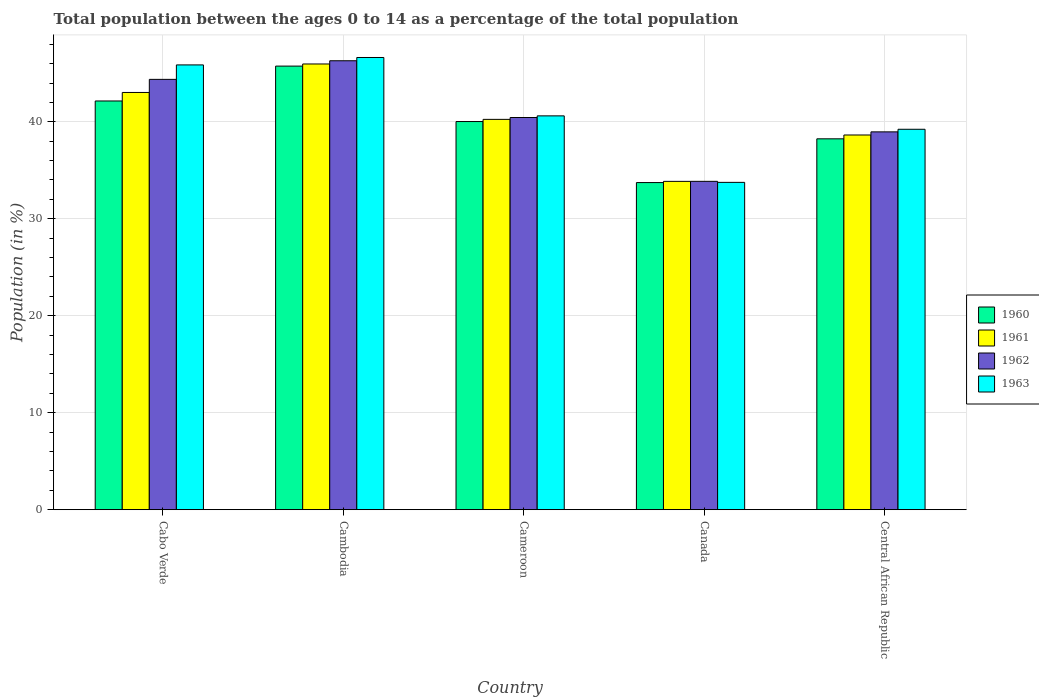Are the number of bars per tick equal to the number of legend labels?
Offer a terse response. Yes. Are the number of bars on each tick of the X-axis equal?
Offer a terse response. Yes. How many bars are there on the 5th tick from the left?
Provide a succinct answer. 4. How many bars are there on the 2nd tick from the right?
Provide a succinct answer. 4. What is the label of the 2nd group of bars from the left?
Provide a succinct answer. Cambodia. What is the percentage of the population ages 0 to 14 in 1962 in Cabo Verde?
Ensure brevity in your answer.  44.38. Across all countries, what is the maximum percentage of the population ages 0 to 14 in 1963?
Offer a very short reply. 46.63. Across all countries, what is the minimum percentage of the population ages 0 to 14 in 1963?
Provide a short and direct response. 33.75. In which country was the percentage of the population ages 0 to 14 in 1961 maximum?
Your answer should be very brief. Cambodia. In which country was the percentage of the population ages 0 to 14 in 1961 minimum?
Give a very brief answer. Canada. What is the total percentage of the population ages 0 to 14 in 1960 in the graph?
Provide a short and direct response. 199.89. What is the difference between the percentage of the population ages 0 to 14 in 1963 in Cambodia and that in Central African Republic?
Your response must be concise. 7.4. What is the difference between the percentage of the population ages 0 to 14 in 1961 in Cabo Verde and the percentage of the population ages 0 to 14 in 1963 in Cameroon?
Keep it short and to the point. 2.41. What is the average percentage of the population ages 0 to 14 in 1960 per country?
Your answer should be compact. 39.98. What is the difference between the percentage of the population ages 0 to 14 of/in 1963 and percentage of the population ages 0 to 14 of/in 1962 in Canada?
Offer a terse response. -0.11. In how many countries, is the percentage of the population ages 0 to 14 in 1961 greater than 42?
Offer a very short reply. 2. What is the ratio of the percentage of the population ages 0 to 14 in 1961 in Cabo Verde to that in Central African Republic?
Offer a very short reply. 1.11. Is the percentage of the population ages 0 to 14 in 1962 in Canada less than that in Central African Republic?
Give a very brief answer. Yes. Is the difference between the percentage of the population ages 0 to 14 in 1963 in Cabo Verde and Canada greater than the difference between the percentage of the population ages 0 to 14 in 1962 in Cabo Verde and Canada?
Provide a succinct answer. Yes. What is the difference between the highest and the second highest percentage of the population ages 0 to 14 in 1960?
Make the answer very short. -2.12. What is the difference between the highest and the lowest percentage of the population ages 0 to 14 in 1960?
Ensure brevity in your answer.  12.01. Is it the case that in every country, the sum of the percentage of the population ages 0 to 14 in 1963 and percentage of the population ages 0 to 14 in 1961 is greater than the sum of percentage of the population ages 0 to 14 in 1960 and percentage of the population ages 0 to 14 in 1962?
Give a very brief answer. No. What does the 3rd bar from the left in Cameroon represents?
Your answer should be compact. 1962. How many countries are there in the graph?
Your response must be concise. 5. What is the difference between two consecutive major ticks on the Y-axis?
Your answer should be compact. 10. Are the values on the major ticks of Y-axis written in scientific E-notation?
Give a very brief answer. No. Does the graph contain any zero values?
Offer a terse response. No. Does the graph contain grids?
Your answer should be compact. Yes. How many legend labels are there?
Offer a very short reply. 4. What is the title of the graph?
Your answer should be compact. Total population between the ages 0 to 14 as a percentage of the total population. What is the label or title of the X-axis?
Make the answer very short. Country. What is the label or title of the Y-axis?
Make the answer very short. Population (in %). What is the Population (in %) in 1960 in Cabo Verde?
Provide a short and direct response. 42.15. What is the Population (in %) of 1961 in Cabo Verde?
Your answer should be very brief. 43.02. What is the Population (in %) in 1962 in Cabo Verde?
Offer a terse response. 44.38. What is the Population (in %) in 1963 in Cabo Verde?
Provide a succinct answer. 45.86. What is the Population (in %) of 1960 in Cambodia?
Your answer should be compact. 45.74. What is the Population (in %) of 1961 in Cambodia?
Give a very brief answer. 45.96. What is the Population (in %) in 1962 in Cambodia?
Ensure brevity in your answer.  46.29. What is the Population (in %) in 1963 in Cambodia?
Offer a terse response. 46.63. What is the Population (in %) in 1960 in Cameroon?
Offer a very short reply. 40.03. What is the Population (in %) of 1961 in Cameroon?
Keep it short and to the point. 40.25. What is the Population (in %) in 1962 in Cameroon?
Provide a short and direct response. 40.44. What is the Population (in %) in 1963 in Cameroon?
Your response must be concise. 40.61. What is the Population (in %) of 1960 in Canada?
Offer a very short reply. 33.73. What is the Population (in %) of 1961 in Canada?
Provide a short and direct response. 33.86. What is the Population (in %) in 1962 in Canada?
Your answer should be compact. 33.86. What is the Population (in %) of 1963 in Canada?
Ensure brevity in your answer.  33.75. What is the Population (in %) in 1960 in Central African Republic?
Provide a succinct answer. 38.24. What is the Population (in %) of 1961 in Central African Republic?
Offer a terse response. 38.64. What is the Population (in %) in 1962 in Central African Republic?
Your response must be concise. 38.96. What is the Population (in %) in 1963 in Central African Republic?
Your answer should be compact. 39.23. Across all countries, what is the maximum Population (in %) in 1960?
Your response must be concise. 45.74. Across all countries, what is the maximum Population (in %) of 1961?
Provide a succinct answer. 45.96. Across all countries, what is the maximum Population (in %) in 1962?
Your response must be concise. 46.29. Across all countries, what is the maximum Population (in %) of 1963?
Offer a terse response. 46.63. Across all countries, what is the minimum Population (in %) of 1960?
Your answer should be very brief. 33.73. Across all countries, what is the minimum Population (in %) in 1961?
Offer a terse response. 33.86. Across all countries, what is the minimum Population (in %) in 1962?
Ensure brevity in your answer.  33.86. Across all countries, what is the minimum Population (in %) of 1963?
Your answer should be very brief. 33.75. What is the total Population (in %) of 1960 in the graph?
Ensure brevity in your answer.  199.89. What is the total Population (in %) in 1961 in the graph?
Provide a short and direct response. 201.73. What is the total Population (in %) of 1962 in the graph?
Your response must be concise. 203.93. What is the total Population (in %) of 1963 in the graph?
Provide a succinct answer. 206.09. What is the difference between the Population (in %) of 1960 in Cabo Verde and that in Cambodia?
Offer a very short reply. -3.6. What is the difference between the Population (in %) of 1961 in Cabo Verde and that in Cambodia?
Give a very brief answer. -2.94. What is the difference between the Population (in %) of 1962 in Cabo Verde and that in Cambodia?
Provide a short and direct response. -1.92. What is the difference between the Population (in %) of 1963 in Cabo Verde and that in Cambodia?
Offer a very short reply. -0.77. What is the difference between the Population (in %) of 1960 in Cabo Verde and that in Cameroon?
Offer a terse response. 2.12. What is the difference between the Population (in %) of 1961 in Cabo Verde and that in Cameroon?
Keep it short and to the point. 2.78. What is the difference between the Population (in %) of 1962 in Cabo Verde and that in Cameroon?
Offer a terse response. 3.93. What is the difference between the Population (in %) of 1963 in Cabo Verde and that in Cameroon?
Offer a terse response. 5.25. What is the difference between the Population (in %) in 1960 in Cabo Verde and that in Canada?
Your answer should be compact. 8.41. What is the difference between the Population (in %) in 1961 in Cabo Verde and that in Canada?
Your response must be concise. 9.17. What is the difference between the Population (in %) in 1962 in Cabo Verde and that in Canada?
Offer a terse response. 10.52. What is the difference between the Population (in %) of 1963 in Cabo Verde and that in Canada?
Provide a succinct answer. 12.11. What is the difference between the Population (in %) of 1960 in Cabo Verde and that in Central African Republic?
Offer a terse response. 3.9. What is the difference between the Population (in %) of 1961 in Cabo Verde and that in Central African Republic?
Give a very brief answer. 4.39. What is the difference between the Population (in %) of 1962 in Cabo Verde and that in Central African Republic?
Your answer should be very brief. 5.41. What is the difference between the Population (in %) in 1963 in Cabo Verde and that in Central African Republic?
Provide a succinct answer. 6.64. What is the difference between the Population (in %) of 1960 in Cambodia and that in Cameroon?
Ensure brevity in your answer.  5.72. What is the difference between the Population (in %) of 1961 in Cambodia and that in Cameroon?
Your answer should be very brief. 5.71. What is the difference between the Population (in %) of 1962 in Cambodia and that in Cameroon?
Provide a short and direct response. 5.85. What is the difference between the Population (in %) of 1963 in Cambodia and that in Cameroon?
Your answer should be compact. 6.02. What is the difference between the Population (in %) in 1960 in Cambodia and that in Canada?
Provide a succinct answer. 12.01. What is the difference between the Population (in %) in 1961 in Cambodia and that in Canada?
Your answer should be very brief. 12.11. What is the difference between the Population (in %) of 1962 in Cambodia and that in Canada?
Offer a very short reply. 12.43. What is the difference between the Population (in %) in 1963 in Cambodia and that in Canada?
Offer a terse response. 12.88. What is the difference between the Population (in %) of 1960 in Cambodia and that in Central African Republic?
Your answer should be compact. 7.5. What is the difference between the Population (in %) in 1961 in Cambodia and that in Central African Republic?
Offer a very short reply. 7.32. What is the difference between the Population (in %) in 1962 in Cambodia and that in Central African Republic?
Keep it short and to the point. 7.33. What is the difference between the Population (in %) in 1963 in Cambodia and that in Central African Republic?
Offer a very short reply. 7.4. What is the difference between the Population (in %) of 1960 in Cameroon and that in Canada?
Your answer should be compact. 6.29. What is the difference between the Population (in %) in 1961 in Cameroon and that in Canada?
Make the answer very short. 6.39. What is the difference between the Population (in %) of 1962 in Cameroon and that in Canada?
Provide a succinct answer. 6.58. What is the difference between the Population (in %) in 1963 in Cameroon and that in Canada?
Make the answer very short. 6.86. What is the difference between the Population (in %) in 1960 in Cameroon and that in Central African Republic?
Offer a very short reply. 1.78. What is the difference between the Population (in %) of 1961 in Cameroon and that in Central African Republic?
Give a very brief answer. 1.61. What is the difference between the Population (in %) in 1962 in Cameroon and that in Central African Republic?
Offer a terse response. 1.48. What is the difference between the Population (in %) of 1963 in Cameroon and that in Central African Republic?
Give a very brief answer. 1.38. What is the difference between the Population (in %) in 1960 in Canada and that in Central African Republic?
Ensure brevity in your answer.  -4.51. What is the difference between the Population (in %) in 1961 in Canada and that in Central African Republic?
Ensure brevity in your answer.  -4.78. What is the difference between the Population (in %) in 1962 in Canada and that in Central African Republic?
Keep it short and to the point. -5.1. What is the difference between the Population (in %) of 1963 in Canada and that in Central African Republic?
Provide a short and direct response. -5.47. What is the difference between the Population (in %) in 1960 in Cabo Verde and the Population (in %) in 1961 in Cambodia?
Your answer should be compact. -3.82. What is the difference between the Population (in %) of 1960 in Cabo Verde and the Population (in %) of 1962 in Cambodia?
Your answer should be very brief. -4.15. What is the difference between the Population (in %) in 1960 in Cabo Verde and the Population (in %) in 1963 in Cambodia?
Provide a short and direct response. -4.48. What is the difference between the Population (in %) in 1961 in Cabo Verde and the Population (in %) in 1962 in Cambodia?
Ensure brevity in your answer.  -3.27. What is the difference between the Population (in %) in 1961 in Cabo Verde and the Population (in %) in 1963 in Cambodia?
Make the answer very short. -3.61. What is the difference between the Population (in %) of 1962 in Cabo Verde and the Population (in %) of 1963 in Cambodia?
Offer a very short reply. -2.26. What is the difference between the Population (in %) in 1960 in Cabo Verde and the Population (in %) in 1961 in Cameroon?
Your answer should be compact. 1.9. What is the difference between the Population (in %) of 1960 in Cabo Verde and the Population (in %) of 1962 in Cameroon?
Offer a very short reply. 1.71. What is the difference between the Population (in %) of 1960 in Cabo Verde and the Population (in %) of 1963 in Cameroon?
Your answer should be very brief. 1.54. What is the difference between the Population (in %) of 1961 in Cabo Verde and the Population (in %) of 1962 in Cameroon?
Offer a very short reply. 2.58. What is the difference between the Population (in %) of 1961 in Cabo Verde and the Population (in %) of 1963 in Cameroon?
Your answer should be very brief. 2.41. What is the difference between the Population (in %) in 1962 in Cabo Verde and the Population (in %) in 1963 in Cameroon?
Make the answer very short. 3.76. What is the difference between the Population (in %) in 1960 in Cabo Verde and the Population (in %) in 1961 in Canada?
Offer a very short reply. 8.29. What is the difference between the Population (in %) of 1960 in Cabo Verde and the Population (in %) of 1962 in Canada?
Make the answer very short. 8.29. What is the difference between the Population (in %) of 1960 in Cabo Verde and the Population (in %) of 1963 in Canada?
Ensure brevity in your answer.  8.39. What is the difference between the Population (in %) in 1961 in Cabo Verde and the Population (in %) in 1962 in Canada?
Make the answer very short. 9.16. What is the difference between the Population (in %) of 1961 in Cabo Verde and the Population (in %) of 1963 in Canada?
Make the answer very short. 9.27. What is the difference between the Population (in %) in 1962 in Cabo Verde and the Population (in %) in 1963 in Canada?
Offer a very short reply. 10.62. What is the difference between the Population (in %) in 1960 in Cabo Verde and the Population (in %) in 1961 in Central African Republic?
Your response must be concise. 3.51. What is the difference between the Population (in %) of 1960 in Cabo Verde and the Population (in %) of 1962 in Central African Republic?
Keep it short and to the point. 3.19. What is the difference between the Population (in %) in 1960 in Cabo Verde and the Population (in %) in 1963 in Central African Republic?
Your response must be concise. 2.92. What is the difference between the Population (in %) of 1961 in Cabo Verde and the Population (in %) of 1962 in Central African Republic?
Give a very brief answer. 4.06. What is the difference between the Population (in %) of 1961 in Cabo Verde and the Population (in %) of 1963 in Central African Republic?
Ensure brevity in your answer.  3.8. What is the difference between the Population (in %) of 1962 in Cabo Verde and the Population (in %) of 1963 in Central African Republic?
Your response must be concise. 5.15. What is the difference between the Population (in %) of 1960 in Cambodia and the Population (in %) of 1961 in Cameroon?
Ensure brevity in your answer.  5.49. What is the difference between the Population (in %) in 1960 in Cambodia and the Population (in %) in 1962 in Cameroon?
Your answer should be compact. 5.3. What is the difference between the Population (in %) in 1960 in Cambodia and the Population (in %) in 1963 in Cameroon?
Ensure brevity in your answer.  5.13. What is the difference between the Population (in %) in 1961 in Cambodia and the Population (in %) in 1962 in Cameroon?
Your response must be concise. 5.52. What is the difference between the Population (in %) of 1961 in Cambodia and the Population (in %) of 1963 in Cameroon?
Make the answer very short. 5.35. What is the difference between the Population (in %) of 1962 in Cambodia and the Population (in %) of 1963 in Cameroon?
Give a very brief answer. 5.68. What is the difference between the Population (in %) in 1960 in Cambodia and the Population (in %) in 1961 in Canada?
Provide a short and direct response. 11.89. What is the difference between the Population (in %) in 1960 in Cambodia and the Population (in %) in 1962 in Canada?
Your response must be concise. 11.88. What is the difference between the Population (in %) in 1960 in Cambodia and the Population (in %) in 1963 in Canada?
Provide a short and direct response. 11.99. What is the difference between the Population (in %) in 1961 in Cambodia and the Population (in %) in 1962 in Canada?
Provide a succinct answer. 12.1. What is the difference between the Population (in %) in 1961 in Cambodia and the Population (in %) in 1963 in Canada?
Make the answer very short. 12.21. What is the difference between the Population (in %) in 1962 in Cambodia and the Population (in %) in 1963 in Canada?
Offer a terse response. 12.54. What is the difference between the Population (in %) of 1960 in Cambodia and the Population (in %) of 1961 in Central African Republic?
Ensure brevity in your answer.  7.1. What is the difference between the Population (in %) of 1960 in Cambodia and the Population (in %) of 1962 in Central African Republic?
Your answer should be very brief. 6.78. What is the difference between the Population (in %) in 1960 in Cambodia and the Population (in %) in 1963 in Central African Republic?
Your answer should be compact. 6.52. What is the difference between the Population (in %) of 1961 in Cambodia and the Population (in %) of 1962 in Central African Republic?
Offer a very short reply. 7. What is the difference between the Population (in %) in 1961 in Cambodia and the Population (in %) in 1963 in Central African Republic?
Your response must be concise. 6.73. What is the difference between the Population (in %) in 1962 in Cambodia and the Population (in %) in 1963 in Central African Republic?
Make the answer very short. 7.07. What is the difference between the Population (in %) in 1960 in Cameroon and the Population (in %) in 1961 in Canada?
Your answer should be very brief. 6.17. What is the difference between the Population (in %) of 1960 in Cameroon and the Population (in %) of 1962 in Canada?
Provide a succinct answer. 6.17. What is the difference between the Population (in %) in 1960 in Cameroon and the Population (in %) in 1963 in Canada?
Offer a very short reply. 6.27. What is the difference between the Population (in %) in 1961 in Cameroon and the Population (in %) in 1962 in Canada?
Make the answer very short. 6.39. What is the difference between the Population (in %) of 1961 in Cameroon and the Population (in %) of 1963 in Canada?
Keep it short and to the point. 6.5. What is the difference between the Population (in %) in 1962 in Cameroon and the Population (in %) in 1963 in Canada?
Ensure brevity in your answer.  6.69. What is the difference between the Population (in %) of 1960 in Cameroon and the Population (in %) of 1961 in Central African Republic?
Give a very brief answer. 1.39. What is the difference between the Population (in %) in 1960 in Cameroon and the Population (in %) in 1962 in Central African Republic?
Your answer should be very brief. 1.07. What is the difference between the Population (in %) of 1960 in Cameroon and the Population (in %) of 1963 in Central African Republic?
Ensure brevity in your answer.  0.8. What is the difference between the Population (in %) of 1961 in Cameroon and the Population (in %) of 1962 in Central African Republic?
Ensure brevity in your answer.  1.29. What is the difference between the Population (in %) of 1961 in Cameroon and the Population (in %) of 1963 in Central African Republic?
Offer a very short reply. 1.02. What is the difference between the Population (in %) of 1962 in Cameroon and the Population (in %) of 1963 in Central African Republic?
Offer a very short reply. 1.21. What is the difference between the Population (in %) of 1960 in Canada and the Population (in %) of 1961 in Central African Republic?
Provide a short and direct response. -4.91. What is the difference between the Population (in %) in 1960 in Canada and the Population (in %) in 1962 in Central African Republic?
Your answer should be compact. -5.23. What is the difference between the Population (in %) of 1960 in Canada and the Population (in %) of 1963 in Central African Republic?
Provide a succinct answer. -5.5. What is the difference between the Population (in %) in 1961 in Canada and the Population (in %) in 1962 in Central African Republic?
Offer a terse response. -5.1. What is the difference between the Population (in %) of 1961 in Canada and the Population (in %) of 1963 in Central African Republic?
Give a very brief answer. -5.37. What is the difference between the Population (in %) in 1962 in Canada and the Population (in %) in 1963 in Central African Republic?
Provide a succinct answer. -5.37. What is the average Population (in %) in 1960 per country?
Ensure brevity in your answer.  39.98. What is the average Population (in %) in 1961 per country?
Your response must be concise. 40.35. What is the average Population (in %) of 1962 per country?
Offer a terse response. 40.79. What is the average Population (in %) of 1963 per country?
Ensure brevity in your answer.  41.22. What is the difference between the Population (in %) in 1960 and Population (in %) in 1961 in Cabo Verde?
Give a very brief answer. -0.88. What is the difference between the Population (in %) of 1960 and Population (in %) of 1962 in Cabo Verde?
Provide a succinct answer. -2.23. What is the difference between the Population (in %) in 1960 and Population (in %) in 1963 in Cabo Verde?
Make the answer very short. -3.72. What is the difference between the Population (in %) of 1961 and Population (in %) of 1962 in Cabo Verde?
Provide a succinct answer. -1.35. What is the difference between the Population (in %) of 1961 and Population (in %) of 1963 in Cabo Verde?
Offer a very short reply. -2.84. What is the difference between the Population (in %) of 1962 and Population (in %) of 1963 in Cabo Verde?
Ensure brevity in your answer.  -1.49. What is the difference between the Population (in %) in 1960 and Population (in %) in 1961 in Cambodia?
Your answer should be compact. -0.22. What is the difference between the Population (in %) in 1960 and Population (in %) in 1962 in Cambodia?
Give a very brief answer. -0.55. What is the difference between the Population (in %) of 1960 and Population (in %) of 1963 in Cambodia?
Your response must be concise. -0.89. What is the difference between the Population (in %) in 1961 and Population (in %) in 1962 in Cambodia?
Your answer should be very brief. -0.33. What is the difference between the Population (in %) of 1961 and Population (in %) of 1963 in Cambodia?
Keep it short and to the point. -0.67. What is the difference between the Population (in %) of 1962 and Population (in %) of 1963 in Cambodia?
Make the answer very short. -0.34. What is the difference between the Population (in %) of 1960 and Population (in %) of 1961 in Cameroon?
Offer a very short reply. -0.22. What is the difference between the Population (in %) in 1960 and Population (in %) in 1962 in Cameroon?
Ensure brevity in your answer.  -0.41. What is the difference between the Population (in %) of 1960 and Population (in %) of 1963 in Cameroon?
Give a very brief answer. -0.58. What is the difference between the Population (in %) of 1961 and Population (in %) of 1962 in Cameroon?
Ensure brevity in your answer.  -0.19. What is the difference between the Population (in %) in 1961 and Population (in %) in 1963 in Cameroon?
Offer a very short reply. -0.36. What is the difference between the Population (in %) of 1962 and Population (in %) of 1963 in Cameroon?
Offer a very short reply. -0.17. What is the difference between the Population (in %) in 1960 and Population (in %) in 1961 in Canada?
Your answer should be compact. -0.12. What is the difference between the Population (in %) of 1960 and Population (in %) of 1962 in Canada?
Keep it short and to the point. -0.13. What is the difference between the Population (in %) in 1960 and Population (in %) in 1963 in Canada?
Ensure brevity in your answer.  -0.02. What is the difference between the Population (in %) in 1961 and Population (in %) in 1962 in Canada?
Keep it short and to the point. -0. What is the difference between the Population (in %) of 1961 and Population (in %) of 1963 in Canada?
Make the answer very short. 0.1. What is the difference between the Population (in %) in 1962 and Population (in %) in 1963 in Canada?
Your answer should be very brief. 0.11. What is the difference between the Population (in %) in 1960 and Population (in %) in 1961 in Central African Republic?
Keep it short and to the point. -0.39. What is the difference between the Population (in %) of 1960 and Population (in %) of 1962 in Central African Republic?
Ensure brevity in your answer.  -0.72. What is the difference between the Population (in %) of 1960 and Population (in %) of 1963 in Central African Republic?
Offer a very short reply. -0.98. What is the difference between the Population (in %) of 1961 and Population (in %) of 1962 in Central African Republic?
Provide a short and direct response. -0.32. What is the difference between the Population (in %) in 1961 and Population (in %) in 1963 in Central African Republic?
Make the answer very short. -0.59. What is the difference between the Population (in %) in 1962 and Population (in %) in 1963 in Central African Republic?
Provide a short and direct response. -0.27. What is the ratio of the Population (in %) in 1960 in Cabo Verde to that in Cambodia?
Provide a short and direct response. 0.92. What is the ratio of the Population (in %) in 1961 in Cabo Verde to that in Cambodia?
Offer a terse response. 0.94. What is the ratio of the Population (in %) in 1962 in Cabo Verde to that in Cambodia?
Offer a terse response. 0.96. What is the ratio of the Population (in %) in 1963 in Cabo Verde to that in Cambodia?
Your answer should be compact. 0.98. What is the ratio of the Population (in %) of 1960 in Cabo Verde to that in Cameroon?
Your answer should be very brief. 1.05. What is the ratio of the Population (in %) in 1961 in Cabo Verde to that in Cameroon?
Your answer should be compact. 1.07. What is the ratio of the Population (in %) in 1962 in Cabo Verde to that in Cameroon?
Keep it short and to the point. 1.1. What is the ratio of the Population (in %) of 1963 in Cabo Verde to that in Cameroon?
Keep it short and to the point. 1.13. What is the ratio of the Population (in %) of 1960 in Cabo Verde to that in Canada?
Give a very brief answer. 1.25. What is the ratio of the Population (in %) of 1961 in Cabo Verde to that in Canada?
Your answer should be very brief. 1.27. What is the ratio of the Population (in %) of 1962 in Cabo Verde to that in Canada?
Your answer should be compact. 1.31. What is the ratio of the Population (in %) of 1963 in Cabo Verde to that in Canada?
Make the answer very short. 1.36. What is the ratio of the Population (in %) in 1960 in Cabo Verde to that in Central African Republic?
Provide a succinct answer. 1.1. What is the ratio of the Population (in %) in 1961 in Cabo Verde to that in Central African Republic?
Your answer should be very brief. 1.11. What is the ratio of the Population (in %) of 1962 in Cabo Verde to that in Central African Republic?
Provide a succinct answer. 1.14. What is the ratio of the Population (in %) of 1963 in Cabo Verde to that in Central African Republic?
Provide a succinct answer. 1.17. What is the ratio of the Population (in %) of 1960 in Cambodia to that in Cameroon?
Your answer should be compact. 1.14. What is the ratio of the Population (in %) in 1961 in Cambodia to that in Cameroon?
Ensure brevity in your answer.  1.14. What is the ratio of the Population (in %) in 1962 in Cambodia to that in Cameroon?
Provide a succinct answer. 1.14. What is the ratio of the Population (in %) of 1963 in Cambodia to that in Cameroon?
Your response must be concise. 1.15. What is the ratio of the Population (in %) in 1960 in Cambodia to that in Canada?
Make the answer very short. 1.36. What is the ratio of the Population (in %) of 1961 in Cambodia to that in Canada?
Keep it short and to the point. 1.36. What is the ratio of the Population (in %) of 1962 in Cambodia to that in Canada?
Your answer should be very brief. 1.37. What is the ratio of the Population (in %) of 1963 in Cambodia to that in Canada?
Offer a very short reply. 1.38. What is the ratio of the Population (in %) of 1960 in Cambodia to that in Central African Republic?
Provide a short and direct response. 1.2. What is the ratio of the Population (in %) in 1961 in Cambodia to that in Central African Republic?
Your answer should be very brief. 1.19. What is the ratio of the Population (in %) of 1962 in Cambodia to that in Central African Republic?
Give a very brief answer. 1.19. What is the ratio of the Population (in %) of 1963 in Cambodia to that in Central African Republic?
Provide a short and direct response. 1.19. What is the ratio of the Population (in %) of 1960 in Cameroon to that in Canada?
Ensure brevity in your answer.  1.19. What is the ratio of the Population (in %) in 1961 in Cameroon to that in Canada?
Your answer should be compact. 1.19. What is the ratio of the Population (in %) of 1962 in Cameroon to that in Canada?
Offer a terse response. 1.19. What is the ratio of the Population (in %) of 1963 in Cameroon to that in Canada?
Provide a succinct answer. 1.2. What is the ratio of the Population (in %) in 1960 in Cameroon to that in Central African Republic?
Ensure brevity in your answer.  1.05. What is the ratio of the Population (in %) in 1961 in Cameroon to that in Central African Republic?
Your answer should be compact. 1.04. What is the ratio of the Population (in %) of 1962 in Cameroon to that in Central African Republic?
Your answer should be compact. 1.04. What is the ratio of the Population (in %) of 1963 in Cameroon to that in Central African Republic?
Provide a succinct answer. 1.04. What is the ratio of the Population (in %) in 1960 in Canada to that in Central African Republic?
Keep it short and to the point. 0.88. What is the ratio of the Population (in %) of 1961 in Canada to that in Central African Republic?
Your answer should be very brief. 0.88. What is the ratio of the Population (in %) of 1962 in Canada to that in Central African Republic?
Your answer should be very brief. 0.87. What is the ratio of the Population (in %) of 1963 in Canada to that in Central African Republic?
Give a very brief answer. 0.86. What is the difference between the highest and the second highest Population (in %) of 1960?
Provide a succinct answer. 3.6. What is the difference between the highest and the second highest Population (in %) in 1961?
Offer a very short reply. 2.94. What is the difference between the highest and the second highest Population (in %) of 1962?
Provide a succinct answer. 1.92. What is the difference between the highest and the second highest Population (in %) of 1963?
Provide a short and direct response. 0.77. What is the difference between the highest and the lowest Population (in %) of 1960?
Provide a succinct answer. 12.01. What is the difference between the highest and the lowest Population (in %) of 1961?
Your response must be concise. 12.11. What is the difference between the highest and the lowest Population (in %) in 1962?
Ensure brevity in your answer.  12.43. What is the difference between the highest and the lowest Population (in %) in 1963?
Your answer should be compact. 12.88. 